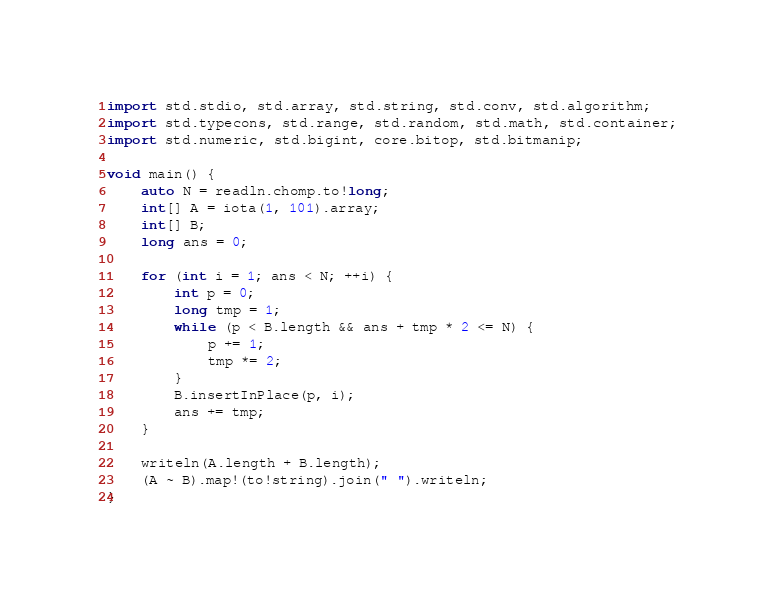Convert code to text. <code><loc_0><loc_0><loc_500><loc_500><_D_>import std.stdio, std.array, std.string, std.conv, std.algorithm;
import std.typecons, std.range, std.random, std.math, std.container;
import std.numeric, std.bigint, core.bitop, std.bitmanip;

void main() {
    auto N = readln.chomp.to!long;
    int[] A = iota(1, 101).array;
    int[] B;
    long ans = 0;

    for (int i = 1; ans < N; ++i) {
        int p = 0;
        long tmp = 1;
        while (p < B.length && ans + tmp * 2 <= N) {
            p += 1;
            tmp *= 2;
        }
        B.insertInPlace(p, i);
        ans += tmp;
    }

    writeln(A.length + B.length);
    (A ~ B).map!(to!string).join(" ").writeln;
}
</code> 